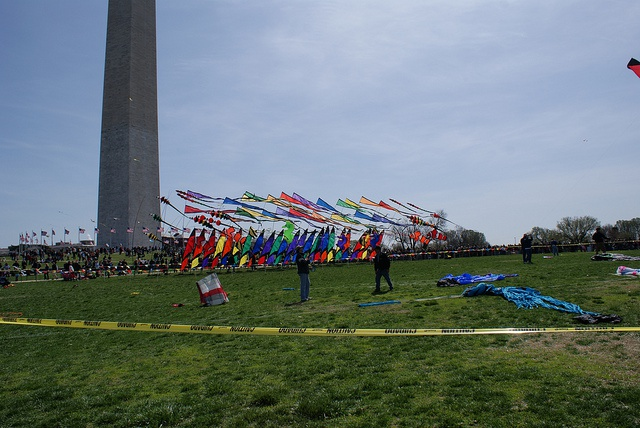Describe the objects in this image and their specific colors. I can see kite in gray, black, darkgreen, and blue tones, kite in gray, black, maroon, and blue tones, people in gray, black, navy, and darkgreen tones, people in gray, black, darkgreen, and maroon tones, and people in gray, black, and darkblue tones in this image. 